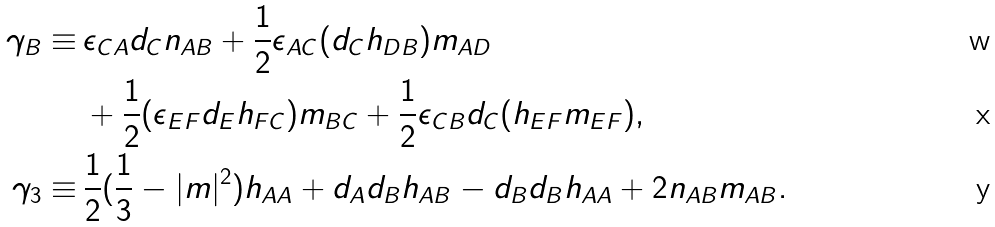<formula> <loc_0><loc_0><loc_500><loc_500>\gamma _ { B } \equiv \, & \epsilon _ { C A } d _ { C } n _ { A B } + \frac { 1 } { 2 } \epsilon _ { A C } ( d _ { C } h _ { D B } ) m _ { A D } \\ & + \frac { 1 } { 2 } ( \epsilon _ { E F } d _ { E } h _ { F C } ) m _ { B C } + \frac { 1 } { 2 } \epsilon _ { C B } d _ { C } ( h _ { E F } m _ { E F } ) , \\ \gamma _ { 3 } \equiv \, & \frac { 1 } { 2 } ( \frac { 1 } { 3 } - | m | ^ { 2 } ) h _ { A A } + d _ { A } d _ { B } h _ { A B } - d _ { B } d _ { B } h _ { A A } + 2 n _ { A B } m _ { A B } .</formula> 